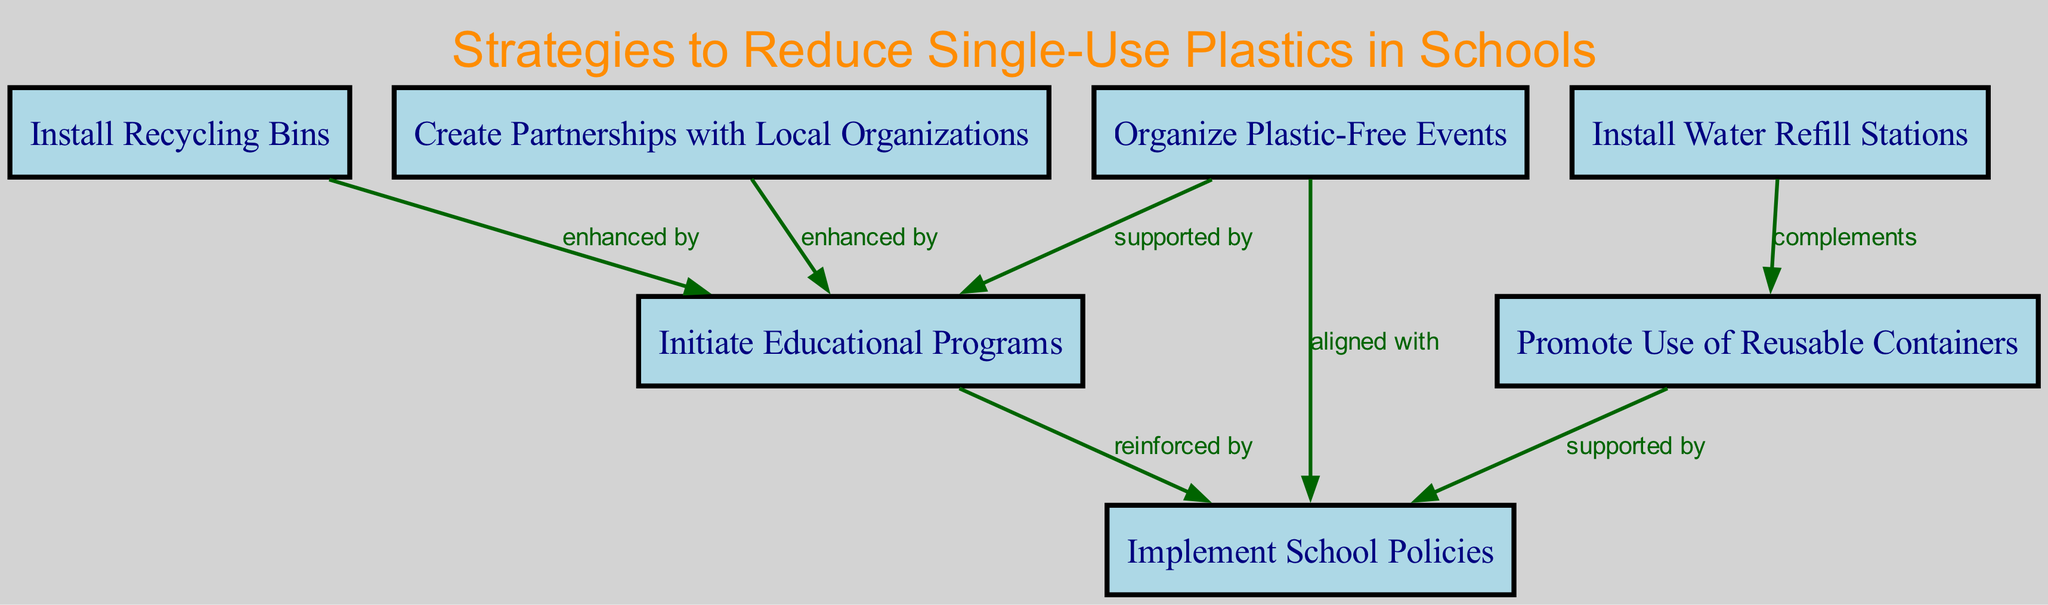What is the total number of nodes in the diagram? The diagram comprises a total of 6 unique nodes, which represent various strategies to reduce single-use plastics in schools.
Answer: 6 Which node is enhanced by Recycling Bins? The Recycling Bins node enhances the Educational Programs node, as indicated by the directional edge in the diagram showing a supportive relationship between these two nodes.
Answer: Educational Programs What relationship exists between Policy Changes and Reusable Containers? The diagram specifies that the relationship between Policy Changes and Reusable Containers is that the latter is supported by the former, indicating that promoting reusable containers is backed by school policy changes.
Answer: supported by Which node supports Plastic-Free Events? The diagram indicates that Educational Programs supports Plastic-Free Events, meaning that educational initiatives help facilitate such events to minimize plastic use.
Answer: Educational Programs How many edges are in the diagram? The diagram illustrates a total of 7 edges, which represent the different relationships connecting the nodes reflecting various strategies to reduce plastic use.
Answer: 7 Which two nodes are aligned with each other? The node for Policy Changes is aligned with the node for Plastic-Free Events, indicating a coordinated strategy toward reducing plastic waste in both policies and event planning.
Answer: Policy Changes and Plastic-Free Events Which strategy complements the installation of Water Refill Stations? The diagram shows that Reusable Containers complements the installation of Water Refill Stations, suggesting that having refill stations encourages the use of reusable containers for drinking water.
Answer: Reusable Containers What initiative is reinforced by Educational Programs? The diagram states that Policy Changes are reinforced by Educational Programs, implying that educational efforts enhance the effectiveness of the policies established to reduce plastic waste.
Answer: Policy Changes Which two nodes are enhanced by Partnerships? According to the diagram, Partnerships enhance both Educational Programs and Recycling Bins, indicating that collaborating with local organizations strengthens educational initiatives and waste disposal practices.
Answer: Educational Programs and Recycling Bins 